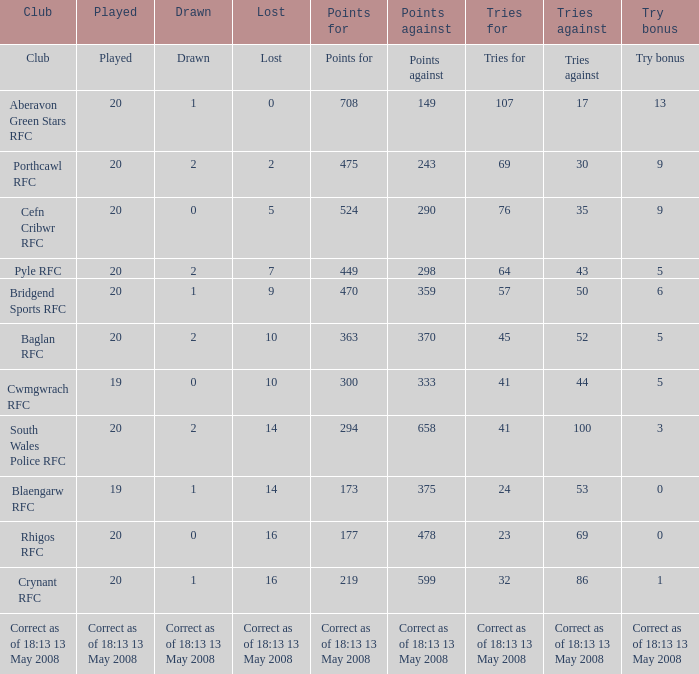What is the points when the try bonus is 1? 219.0. 